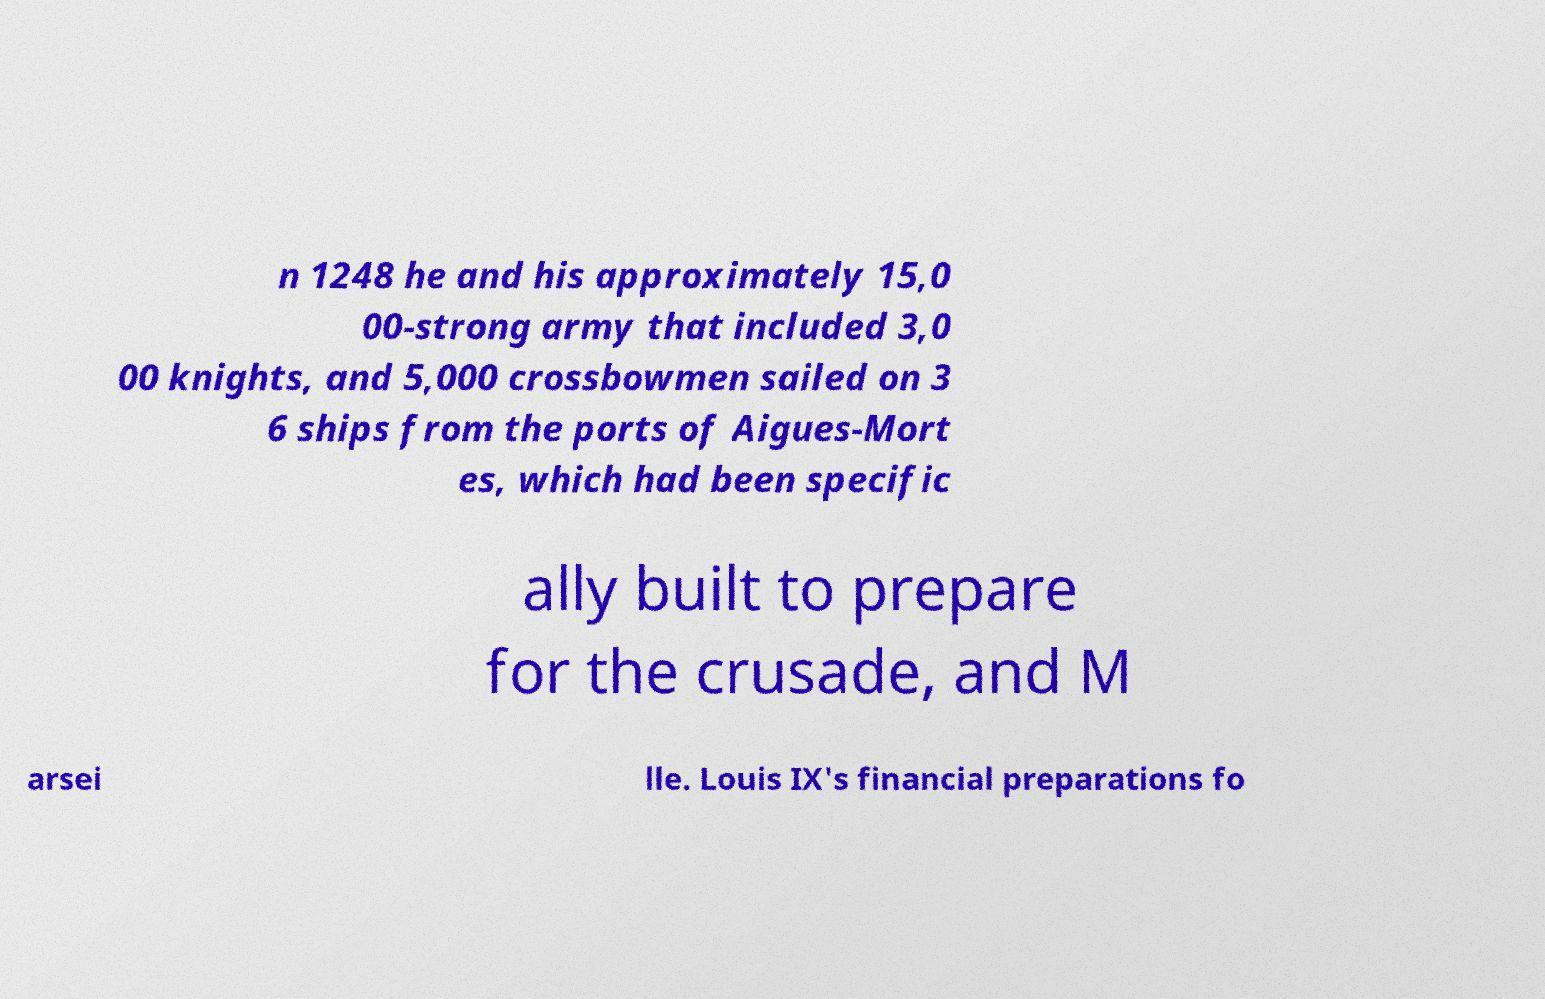Can you read and provide the text displayed in the image?This photo seems to have some interesting text. Can you extract and type it out for me? n 1248 he and his approximately 15,0 00-strong army that included 3,0 00 knights, and 5,000 crossbowmen sailed on 3 6 ships from the ports of Aigues-Mort es, which had been specific ally built to prepare for the crusade, and M arsei lle. Louis IX's financial preparations fo 